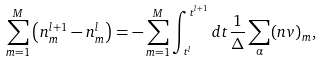Convert formula to latex. <formula><loc_0><loc_0><loc_500><loc_500>\sum _ { m = 1 } ^ { M } \left ( n _ { m } ^ { l + 1 } - n _ { m } ^ { l } \right ) = - \sum _ { m = 1 } ^ { M } \int _ { t ^ { l } } ^ { t ^ { l + 1 } } d t \frac { 1 } { \Delta } \sum _ { \alpha } ( n v ) _ { m } ,</formula> 